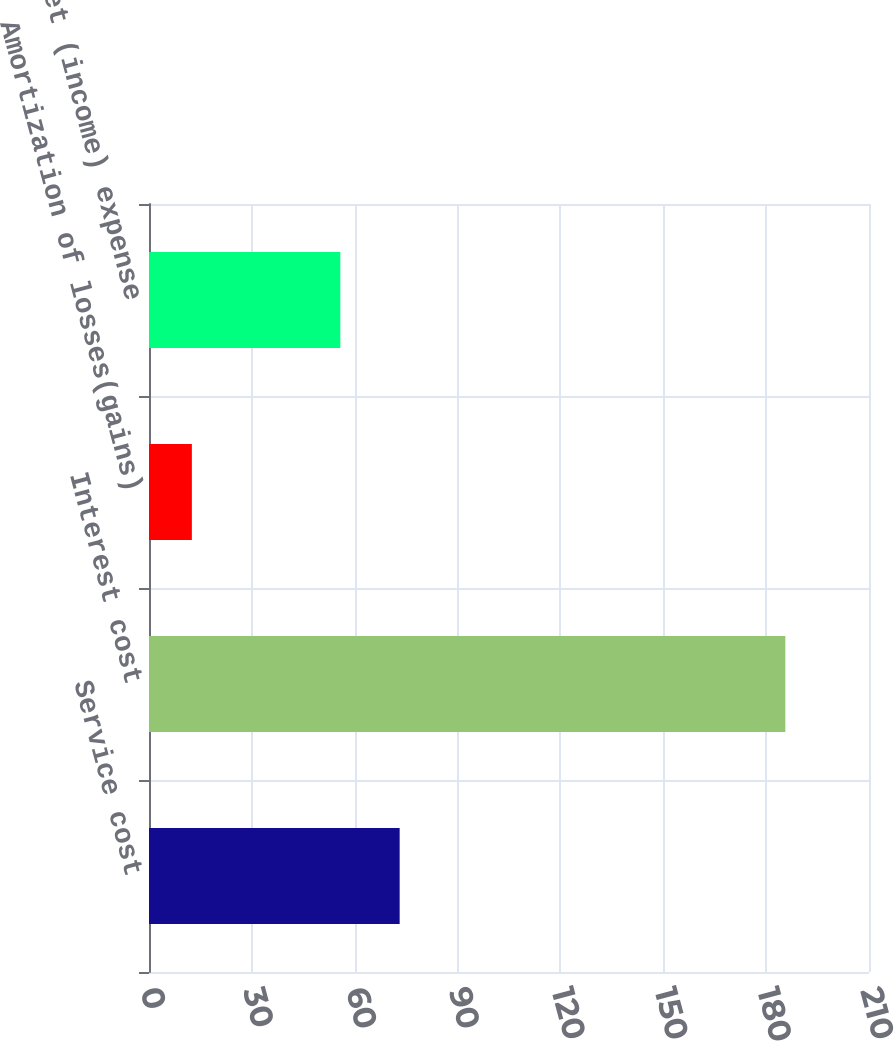<chart> <loc_0><loc_0><loc_500><loc_500><bar_chart><fcel>Service cost<fcel>Interest cost<fcel>Amortization of losses(gains)<fcel>Net (income) expense<nl><fcel>73.11<fcel>185.6<fcel>12.5<fcel>55.8<nl></chart> 